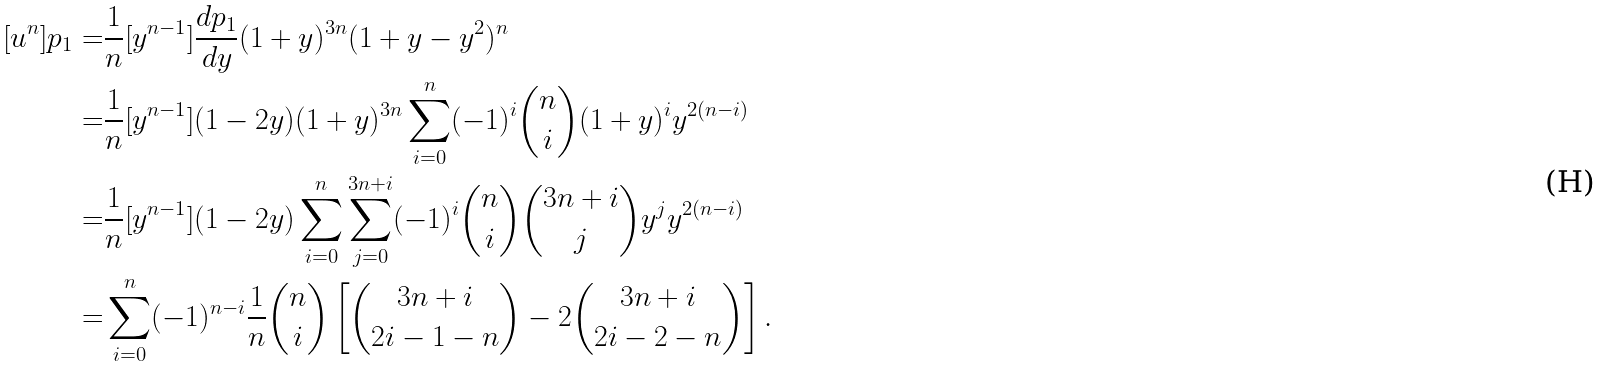Convert formula to latex. <formula><loc_0><loc_0><loc_500><loc_500>[ u ^ { n } ] p _ { 1 } = & \frac { 1 } { n } [ y ^ { n - 1 } ] \frac { d p _ { 1 } } { d y } ( 1 + y ) ^ { 3 n } ( 1 + y - y ^ { 2 } ) ^ { n } \\ = & \frac { 1 } { n } [ y ^ { n - 1 } ] ( 1 - 2 y ) ( 1 + y ) ^ { 3 n } \sum _ { i = 0 } ^ { n } ( - 1 ) ^ { i } \binom { n } { i } ( 1 + y ) ^ { i } y ^ { 2 ( n - i ) } \\ = & \frac { 1 } { n } [ y ^ { n - 1 } ] ( 1 - 2 y ) \sum _ { i = 0 } ^ { n } \sum _ { j = 0 } ^ { 3 n + i } ( - 1 ) ^ { i } \binom { n } { i } \binom { 3 n + i } { j } y ^ { j } y ^ { 2 ( n - i ) } \\ = & \sum _ { i = 0 } ^ { n } ( - 1 ) ^ { n - i } \frac { 1 } { n } \binom { n } { i } \left [ \binom { 3 n + i } { 2 i - 1 - n } - 2 \binom { 3 n + i } { 2 i - 2 - n } \right ] .</formula> 